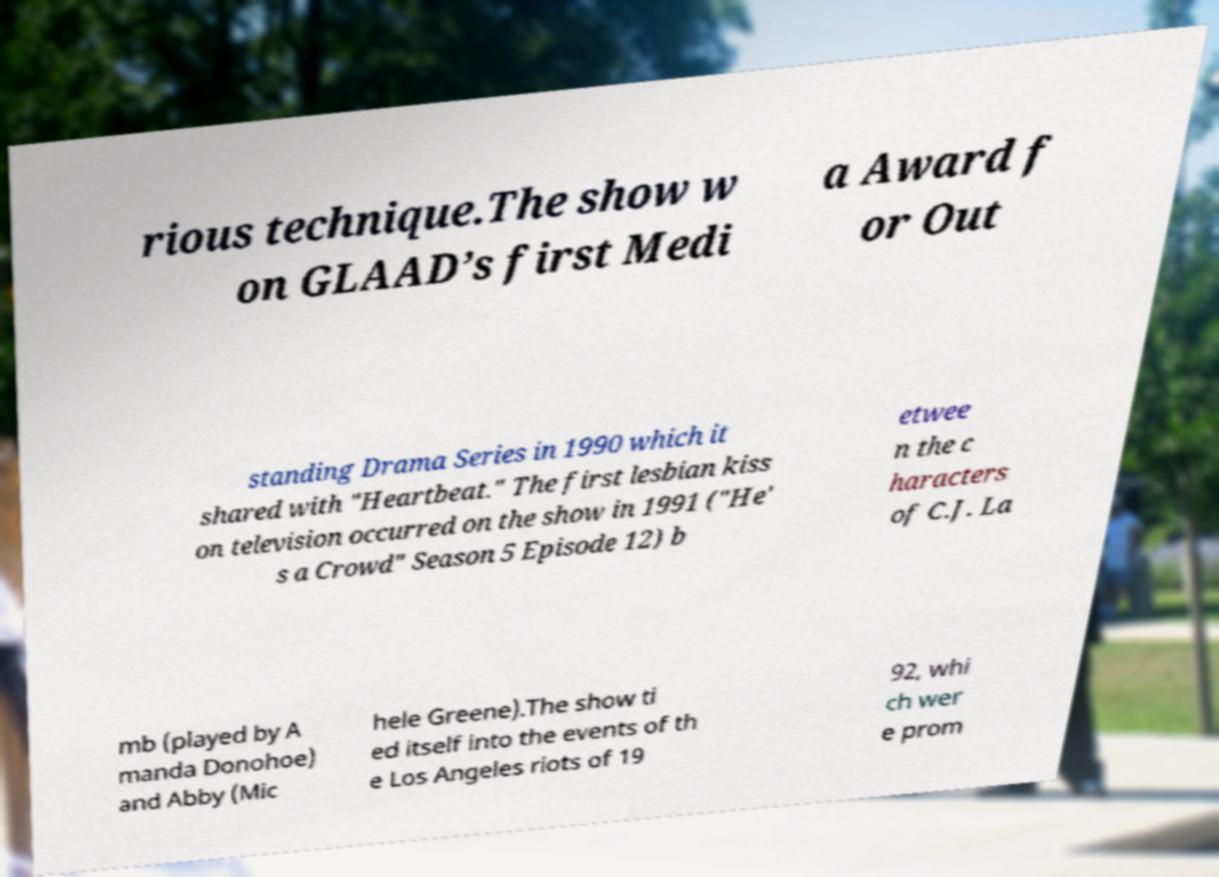Could you assist in decoding the text presented in this image and type it out clearly? rious technique.The show w on GLAAD’s first Medi a Award f or Out standing Drama Series in 1990 which it shared with "Heartbeat." The first lesbian kiss on television occurred on the show in 1991 ("He' s a Crowd" Season 5 Episode 12) b etwee n the c haracters of C.J. La mb (played by A manda Donohoe) and Abby (Mic hele Greene).The show ti ed itself into the events of th e Los Angeles riots of 19 92, whi ch wer e prom 